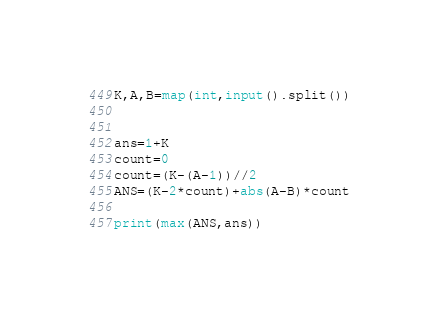<code> <loc_0><loc_0><loc_500><loc_500><_Python_>K,A,B=map(int,input().split())


ans=1+K
count=0
count=(K-(A-1))//2
ANS=(K-2*count)+abs(A-B)*count

print(max(ANS,ans))</code> 